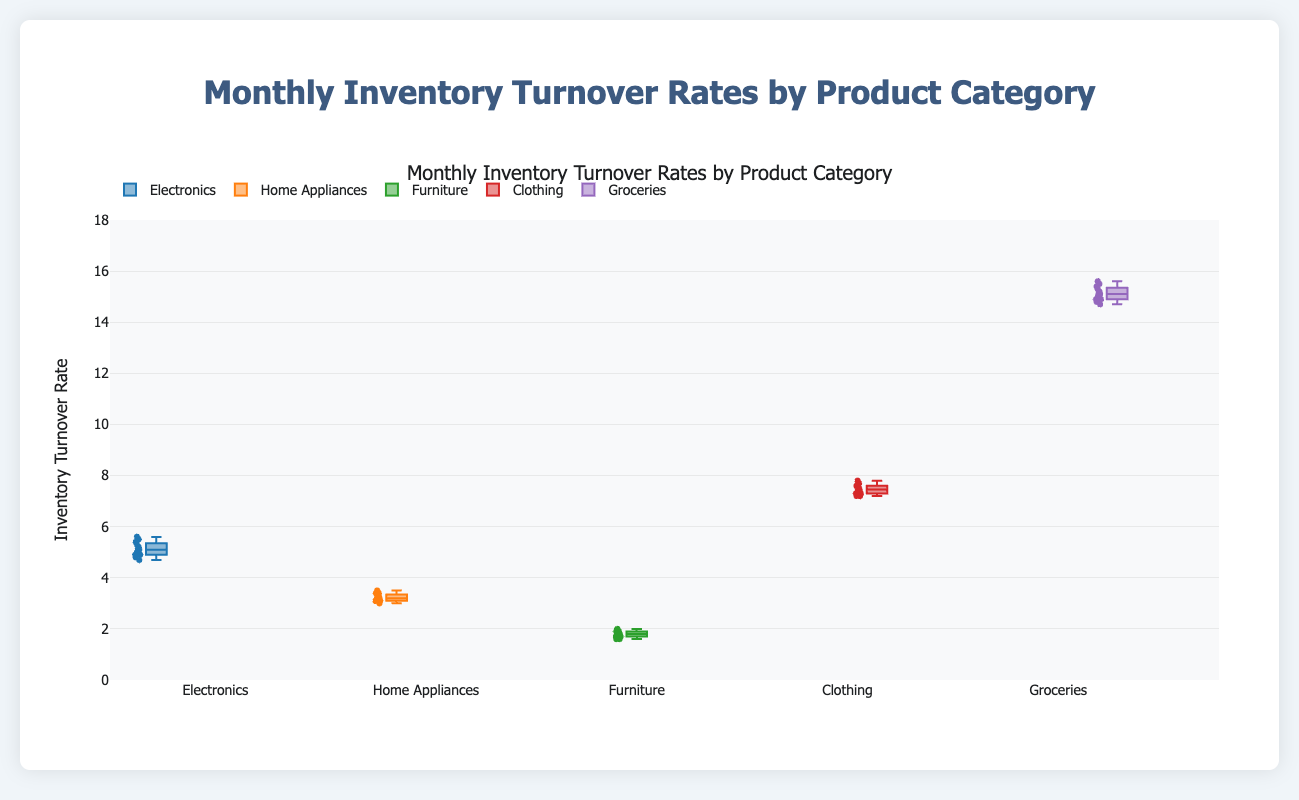What is the median inventory turnover rate for Electronics? The median is the middle value of the sorted turnover rates for Electronics. Sorting the values (4.7, 4.8, 4.9, 4.9, 5.0, 5.1, 5.1, 5.2, 5.3, 5.4, 5.5, 5.6) and taking the middle two (5.1 and 5.1) and averaging them gives the median as 5.1.
Answer: 5.1 Which Product Category has the highest median inventory turnover rate? Find the median value for each category and compare them. The medians are: Electronics (5.1), Home Appliances (3.2), Furniture (1.8), Clothing (7.5), Groceries (15.1). Groceries has the highest median turnover rate.
Answer: Groceries What is the interquartile range (IQR) for the Clothing category? IQR is the difference between the third quartile (Q3) and the first quartile (Q1). For Clothing, Q1 is 7.3 and Q3 is 7.6, so the IQR is 7.6 - 7.3 = 0.3.
Answer: 0.3 How does the spread of turnover rates for Home Appliances compare to Furniture? The spread can be compared by looking at the range (difference between max and min) and the IQR. Home Appliances: Range (3.5 - 3.0 = 0.5), IQR (3.4 - 3.1 = 0.3). Furniture: Range (2.0 - 1.6 = 0.4), IQR (1.9 - 1.7 = 0.2). Home Appliances has a slightly larger spread.
Answer: Home Appliances has a slightly larger spread than Furniture Are there any outliers in the turnover rates for Groceries? Outliers in a box plot are typically indicated by points outside the whiskers. For Groceries, all points appear within the whiskers, indicating no outliers.
Answer: No Which Product Category shows the smallest variability in turnover rates? Variability can be assessed through the IQR and the range. Calculating the IQRs: Electronics (0.6), Home Appliances (0.3), Furniture (0.2), Clothing (0.3), Groceries (0.7). Furniture has the smallest IQR and range (0.4).
Answer: Furniture What is the upper quartile (Q3) for Electronics? Q3 is the median of the upper half of the sorted turnover rates. For Electronics, the sorted rates are (4.7, 4.8, 4.9, 4.9, 5.0, 5.1, 5.1, 5.2, 5.3, 5.4, 5.5, 5.6), and the upper half is (5.1, 5.2, 5.3, 5.4, 5.5, 5.6) with a median of (5.3 + 5.4) / 2 = 5.35.
Answer: 5.35 Which category has a median turnover rate closest to 5? Comparing the medians: Electronics (5.1), Home Appliances (3.2), Furniture (1.8), Clothing (7.5), Groceries (15.1). The median closest to 5 is Electronics (5.1).
Answer: Electronics 